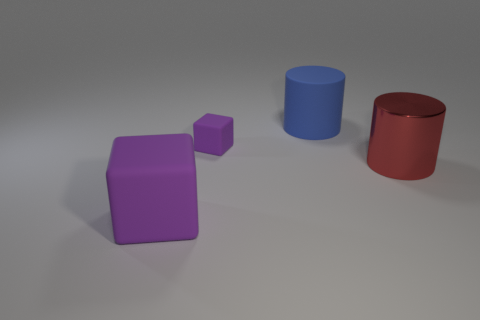Subtract all brown blocks. Subtract all red spheres. How many blocks are left? 2 Add 4 small gray metallic cylinders. How many objects exist? 8 Subtract all big purple rubber blocks. Subtract all big cubes. How many objects are left? 2 Add 4 big blue rubber cylinders. How many big blue rubber cylinders are left? 5 Add 1 large blue rubber cubes. How many large blue rubber cubes exist? 1 Subtract 0 blue balls. How many objects are left? 4 